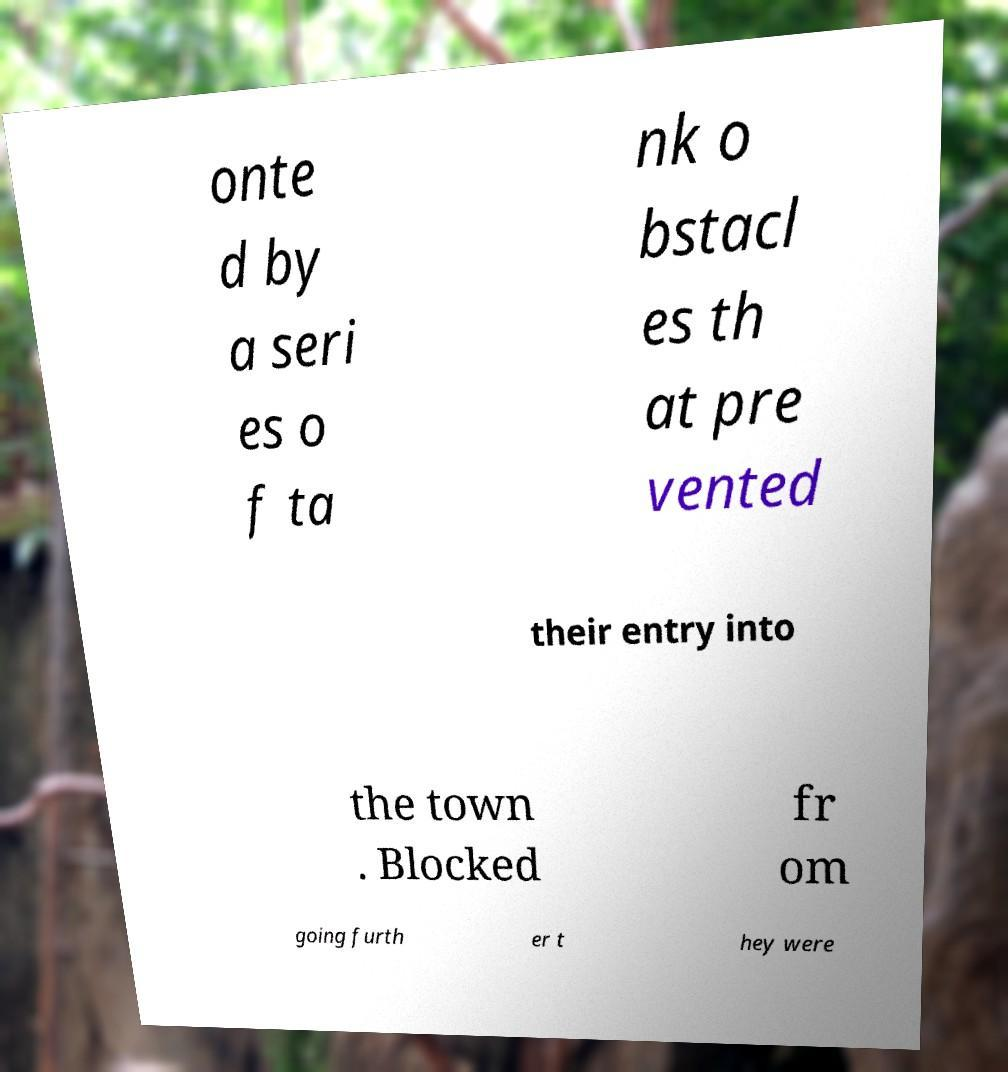Please read and relay the text visible in this image. What does it say? onte d by a seri es o f ta nk o bstacl es th at pre vented their entry into the town . Blocked fr om going furth er t hey were 